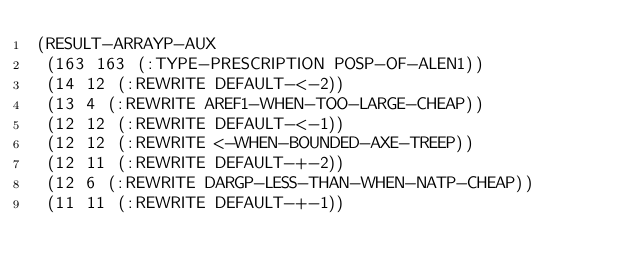<code> <loc_0><loc_0><loc_500><loc_500><_Lisp_>(RESULT-ARRAYP-AUX
 (163 163 (:TYPE-PRESCRIPTION POSP-OF-ALEN1))
 (14 12 (:REWRITE DEFAULT-<-2))
 (13 4 (:REWRITE AREF1-WHEN-TOO-LARGE-CHEAP))
 (12 12 (:REWRITE DEFAULT-<-1))
 (12 12 (:REWRITE <-WHEN-BOUNDED-AXE-TREEP))
 (12 11 (:REWRITE DEFAULT-+-2))
 (12 6 (:REWRITE DARGP-LESS-THAN-WHEN-NATP-CHEAP))
 (11 11 (:REWRITE DEFAULT-+-1))</code> 